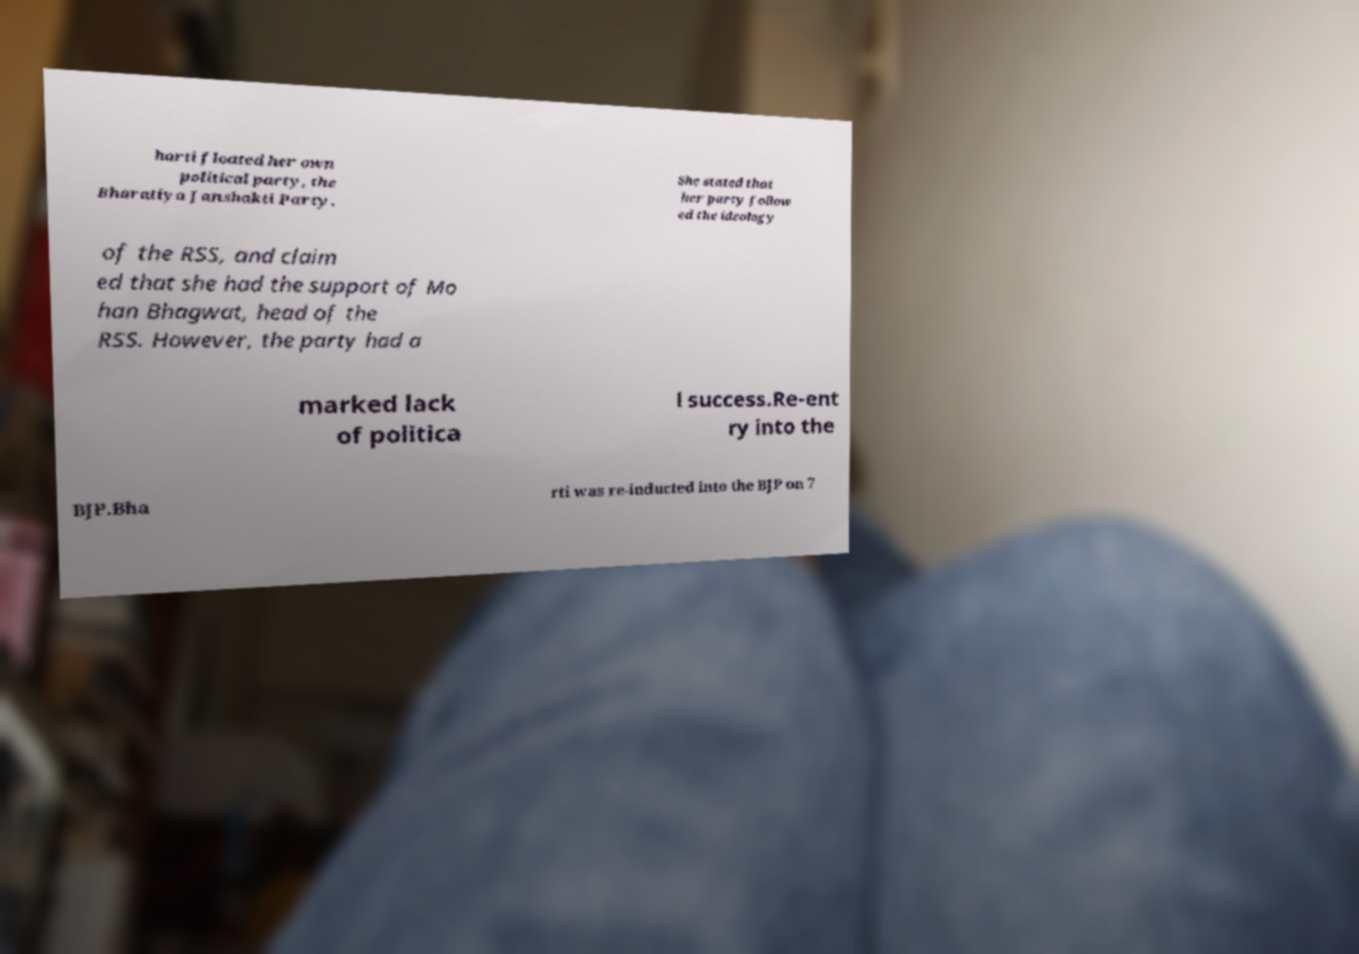Please read and relay the text visible in this image. What does it say? harti floated her own political party, the Bharatiya Janshakti Party. She stated that her party follow ed the ideology of the RSS, and claim ed that she had the support of Mo han Bhagwat, head of the RSS. However, the party had a marked lack of politica l success.Re-ent ry into the BJP.Bha rti was re-inducted into the BJP on 7 